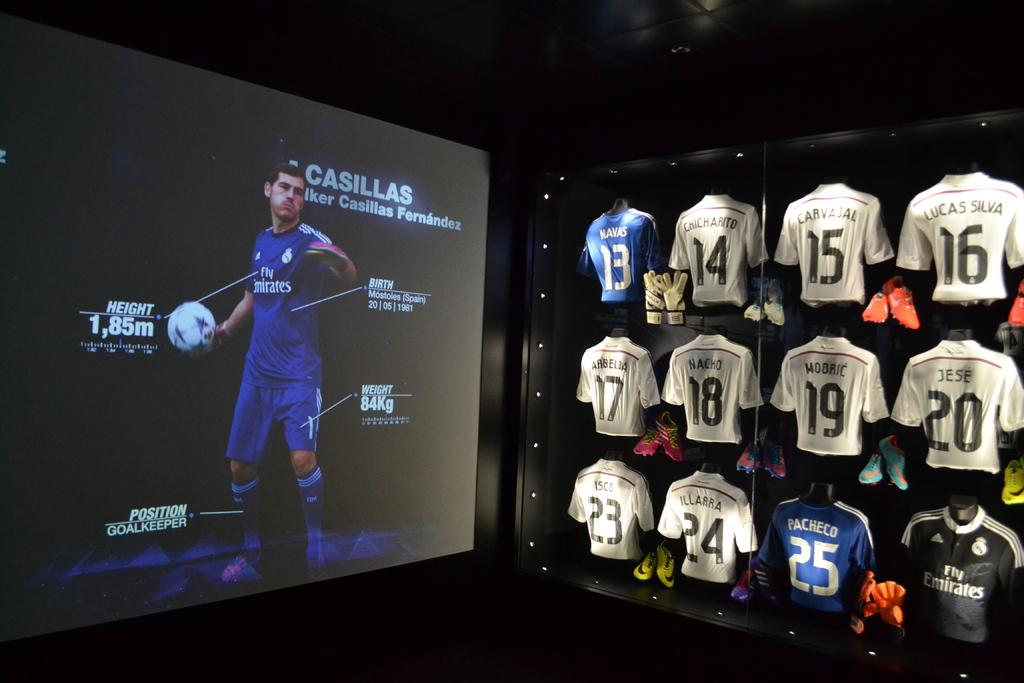How tall is the athlete?
Give a very brief answer. 1,85m. What is the name of the player?
Make the answer very short. Casillas. 